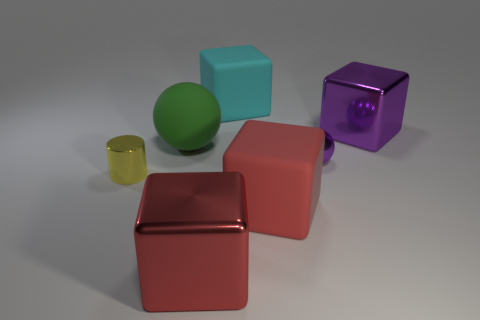Is there any other thing that is the same material as the big cyan cube?
Your answer should be compact. Yes. What shape is the large shiny object behind the large rubber object in front of the green rubber sphere?
Give a very brief answer. Cube. What is the shape of the rubber thing behind the purple shiny block?
Offer a terse response. Cube. What number of metal things are the same color as the tiny shiny ball?
Ensure brevity in your answer.  1. What is the color of the cylinder?
Provide a succinct answer. Yellow. There is a large metallic cube that is in front of the tiny cylinder; how many large red shiny objects are in front of it?
Offer a very short reply. 0. There is a purple block; does it have the same size as the ball to the right of the cyan rubber object?
Provide a short and direct response. No. Is the size of the red metallic thing the same as the purple metallic cube?
Keep it short and to the point. Yes. Is there a brown object that has the same size as the green rubber ball?
Make the answer very short. No. There is a tiny thing in front of the small purple metallic sphere; what is its material?
Give a very brief answer. Metal. 